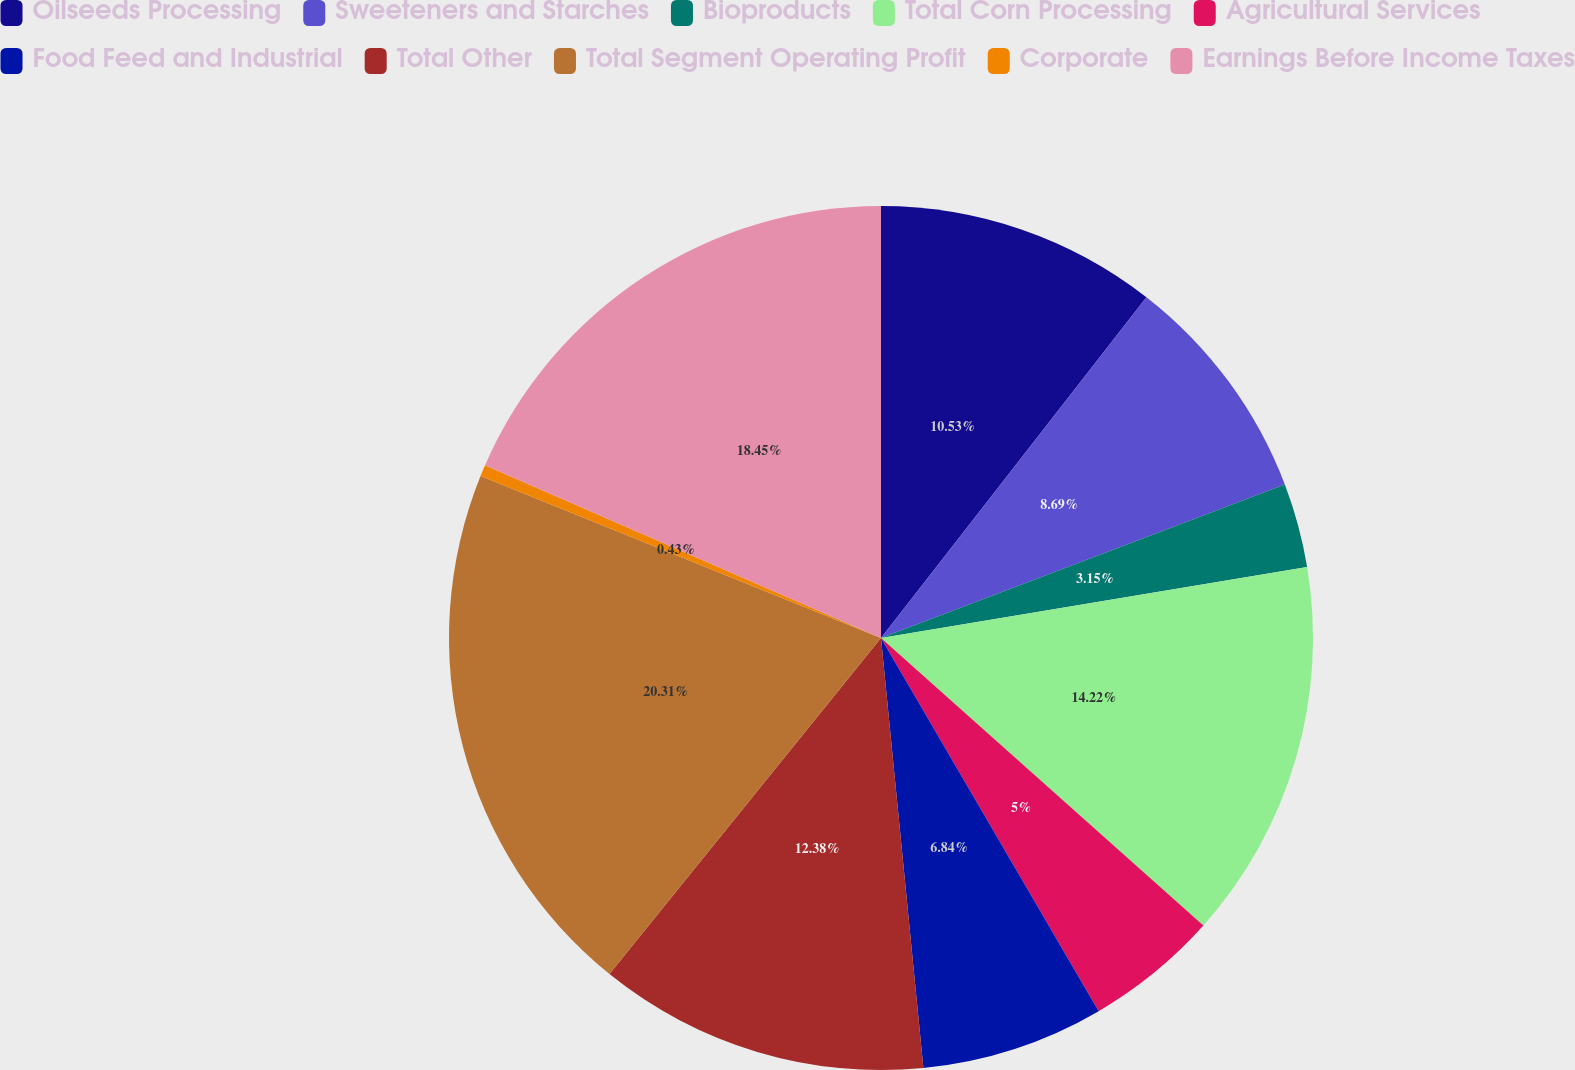Convert chart to OTSL. <chart><loc_0><loc_0><loc_500><loc_500><pie_chart><fcel>Oilseeds Processing<fcel>Sweeteners and Starches<fcel>Bioproducts<fcel>Total Corn Processing<fcel>Agricultural Services<fcel>Food Feed and Industrial<fcel>Total Other<fcel>Total Segment Operating Profit<fcel>Corporate<fcel>Earnings Before Income Taxes<nl><fcel>10.53%<fcel>8.69%<fcel>3.15%<fcel>14.22%<fcel>5.0%<fcel>6.84%<fcel>12.38%<fcel>20.3%<fcel>0.43%<fcel>18.45%<nl></chart> 